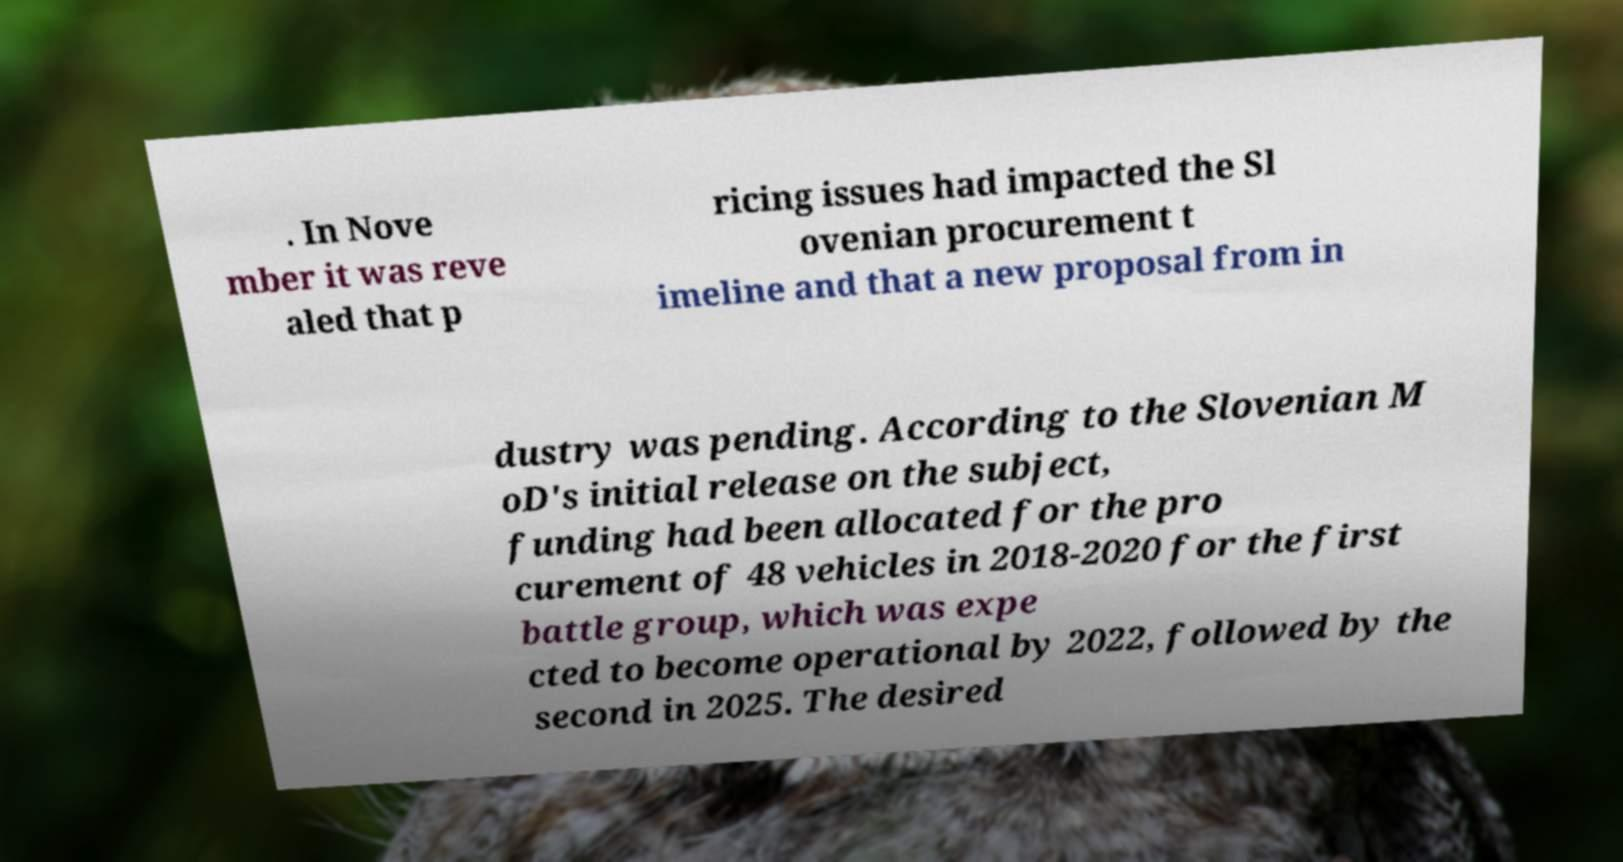I need the written content from this picture converted into text. Can you do that? . In Nove mber it was reve aled that p ricing issues had impacted the Sl ovenian procurement t imeline and that a new proposal from in dustry was pending. According to the Slovenian M oD's initial release on the subject, funding had been allocated for the pro curement of 48 vehicles in 2018-2020 for the first battle group, which was expe cted to become operational by 2022, followed by the second in 2025. The desired 